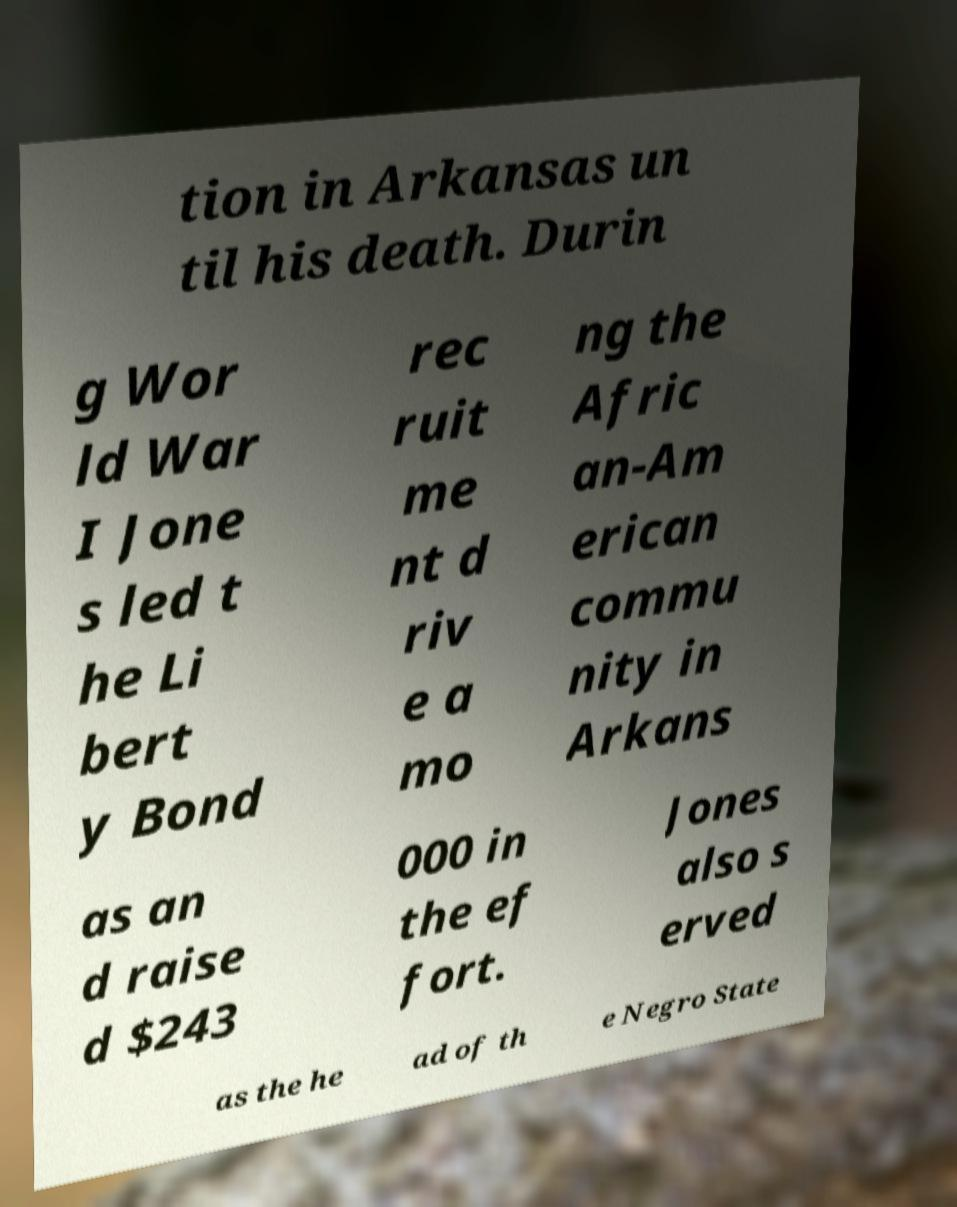What messages or text are displayed in this image? I need them in a readable, typed format. tion in Arkansas un til his death. Durin g Wor ld War I Jone s led t he Li bert y Bond rec ruit me nt d riv e a mo ng the Afric an-Am erican commu nity in Arkans as an d raise d $243 000 in the ef fort. Jones also s erved as the he ad of th e Negro State 